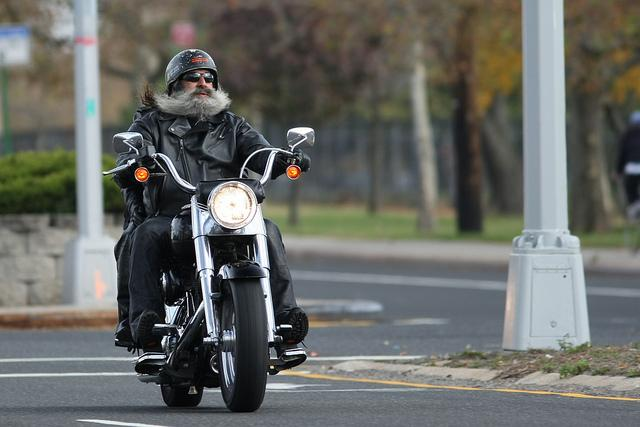What does the brown hair belong to?

Choices:
A) driver's hood
B) someone's hair
C) driver's dog
D) driver's beard someone's hair 